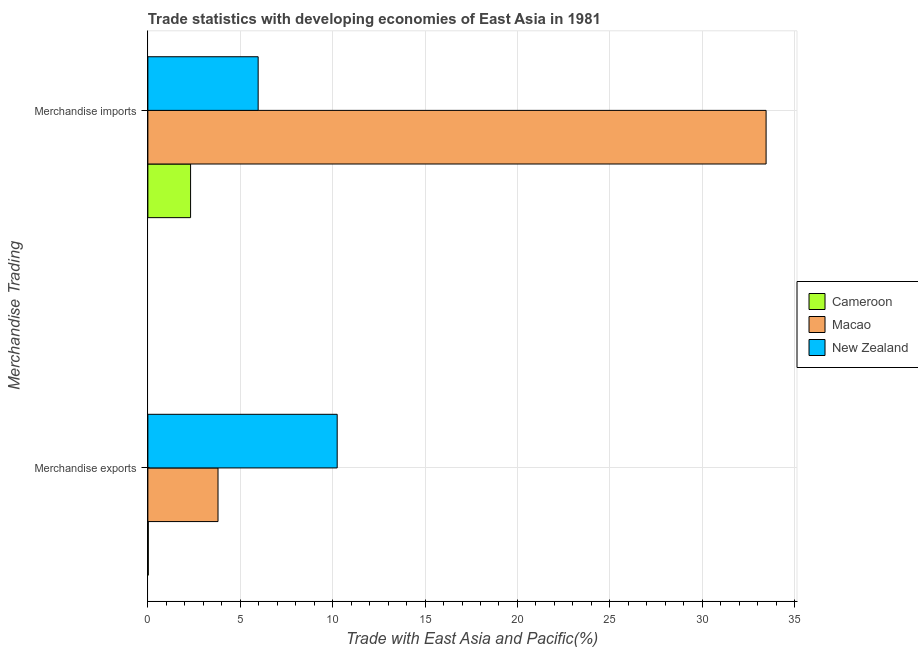How many different coloured bars are there?
Your response must be concise. 3. Are the number of bars on each tick of the Y-axis equal?
Keep it short and to the point. Yes. What is the merchandise exports in Cameroon?
Your answer should be compact. 0.02. Across all countries, what is the maximum merchandise imports?
Keep it short and to the point. 33.46. Across all countries, what is the minimum merchandise exports?
Offer a terse response. 0.02. In which country was the merchandise imports maximum?
Your answer should be very brief. Macao. In which country was the merchandise exports minimum?
Give a very brief answer. Cameroon. What is the total merchandise exports in the graph?
Offer a very short reply. 14.06. What is the difference between the merchandise exports in Macao and that in New Zealand?
Offer a very short reply. -6.45. What is the difference between the merchandise imports in Macao and the merchandise exports in New Zealand?
Your answer should be compact. 23.21. What is the average merchandise imports per country?
Give a very brief answer. 13.91. What is the difference between the merchandise exports and merchandise imports in Cameroon?
Provide a short and direct response. -2.29. What is the ratio of the merchandise exports in Cameroon to that in Macao?
Keep it short and to the point. 0.01. What does the 2nd bar from the top in Merchandise exports represents?
Make the answer very short. Macao. What does the 2nd bar from the bottom in Merchandise exports represents?
Offer a very short reply. Macao. What is the difference between two consecutive major ticks on the X-axis?
Offer a very short reply. 5. Are the values on the major ticks of X-axis written in scientific E-notation?
Your answer should be very brief. No. Does the graph contain grids?
Offer a very short reply. Yes. How many legend labels are there?
Offer a very short reply. 3. What is the title of the graph?
Ensure brevity in your answer.  Trade statistics with developing economies of East Asia in 1981. What is the label or title of the X-axis?
Provide a succinct answer. Trade with East Asia and Pacific(%). What is the label or title of the Y-axis?
Keep it short and to the point. Merchandise Trading. What is the Trade with East Asia and Pacific(%) in Cameroon in Merchandise exports?
Make the answer very short. 0.02. What is the Trade with East Asia and Pacific(%) in Macao in Merchandise exports?
Offer a very short reply. 3.8. What is the Trade with East Asia and Pacific(%) in New Zealand in Merchandise exports?
Your answer should be very brief. 10.25. What is the Trade with East Asia and Pacific(%) in Cameroon in Merchandise imports?
Give a very brief answer. 2.31. What is the Trade with East Asia and Pacific(%) in Macao in Merchandise imports?
Offer a very short reply. 33.46. What is the Trade with East Asia and Pacific(%) of New Zealand in Merchandise imports?
Keep it short and to the point. 5.97. Across all Merchandise Trading, what is the maximum Trade with East Asia and Pacific(%) of Cameroon?
Provide a succinct answer. 2.31. Across all Merchandise Trading, what is the maximum Trade with East Asia and Pacific(%) of Macao?
Offer a terse response. 33.46. Across all Merchandise Trading, what is the maximum Trade with East Asia and Pacific(%) in New Zealand?
Provide a short and direct response. 10.25. Across all Merchandise Trading, what is the minimum Trade with East Asia and Pacific(%) of Cameroon?
Your response must be concise. 0.02. Across all Merchandise Trading, what is the minimum Trade with East Asia and Pacific(%) in Macao?
Offer a terse response. 3.8. Across all Merchandise Trading, what is the minimum Trade with East Asia and Pacific(%) in New Zealand?
Give a very brief answer. 5.97. What is the total Trade with East Asia and Pacific(%) in Cameroon in the graph?
Your answer should be compact. 2.33. What is the total Trade with East Asia and Pacific(%) in Macao in the graph?
Your response must be concise. 37.25. What is the total Trade with East Asia and Pacific(%) of New Zealand in the graph?
Make the answer very short. 16.21. What is the difference between the Trade with East Asia and Pacific(%) of Cameroon in Merchandise exports and that in Merchandise imports?
Offer a very short reply. -2.29. What is the difference between the Trade with East Asia and Pacific(%) in Macao in Merchandise exports and that in Merchandise imports?
Make the answer very short. -29.66. What is the difference between the Trade with East Asia and Pacific(%) in New Zealand in Merchandise exports and that in Merchandise imports?
Your response must be concise. 4.28. What is the difference between the Trade with East Asia and Pacific(%) of Cameroon in Merchandise exports and the Trade with East Asia and Pacific(%) of Macao in Merchandise imports?
Your answer should be very brief. -33.43. What is the difference between the Trade with East Asia and Pacific(%) of Cameroon in Merchandise exports and the Trade with East Asia and Pacific(%) of New Zealand in Merchandise imports?
Your answer should be compact. -5.95. What is the difference between the Trade with East Asia and Pacific(%) of Macao in Merchandise exports and the Trade with East Asia and Pacific(%) of New Zealand in Merchandise imports?
Offer a terse response. -2.17. What is the average Trade with East Asia and Pacific(%) of Cameroon per Merchandise Trading?
Your answer should be very brief. 1.17. What is the average Trade with East Asia and Pacific(%) of Macao per Merchandise Trading?
Give a very brief answer. 18.63. What is the average Trade with East Asia and Pacific(%) of New Zealand per Merchandise Trading?
Offer a terse response. 8.11. What is the difference between the Trade with East Asia and Pacific(%) in Cameroon and Trade with East Asia and Pacific(%) in Macao in Merchandise exports?
Offer a very short reply. -3.77. What is the difference between the Trade with East Asia and Pacific(%) in Cameroon and Trade with East Asia and Pacific(%) in New Zealand in Merchandise exports?
Give a very brief answer. -10.22. What is the difference between the Trade with East Asia and Pacific(%) of Macao and Trade with East Asia and Pacific(%) of New Zealand in Merchandise exports?
Give a very brief answer. -6.45. What is the difference between the Trade with East Asia and Pacific(%) of Cameroon and Trade with East Asia and Pacific(%) of Macao in Merchandise imports?
Your answer should be compact. -31.14. What is the difference between the Trade with East Asia and Pacific(%) of Cameroon and Trade with East Asia and Pacific(%) of New Zealand in Merchandise imports?
Make the answer very short. -3.66. What is the difference between the Trade with East Asia and Pacific(%) of Macao and Trade with East Asia and Pacific(%) of New Zealand in Merchandise imports?
Ensure brevity in your answer.  27.49. What is the ratio of the Trade with East Asia and Pacific(%) of Cameroon in Merchandise exports to that in Merchandise imports?
Your response must be concise. 0.01. What is the ratio of the Trade with East Asia and Pacific(%) of Macao in Merchandise exports to that in Merchandise imports?
Your answer should be compact. 0.11. What is the ratio of the Trade with East Asia and Pacific(%) in New Zealand in Merchandise exports to that in Merchandise imports?
Keep it short and to the point. 1.72. What is the difference between the highest and the second highest Trade with East Asia and Pacific(%) in Cameroon?
Make the answer very short. 2.29. What is the difference between the highest and the second highest Trade with East Asia and Pacific(%) in Macao?
Keep it short and to the point. 29.66. What is the difference between the highest and the second highest Trade with East Asia and Pacific(%) of New Zealand?
Ensure brevity in your answer.  4.28. What is the difference between the highest and the lowest Trade with East Asia and Pacific(%) in Cameroon?
Your answer should be compact. 2.29. What is the difference between the highest and the lowest Trade with East Asia and Pacific(%) of Macao?
Your answer should be very brief. 29.66. What is the difference between the highest and the lowest Trade with East Asia and Pacific(%) in New Zealand?
Offer a very short reply. 4.28. 